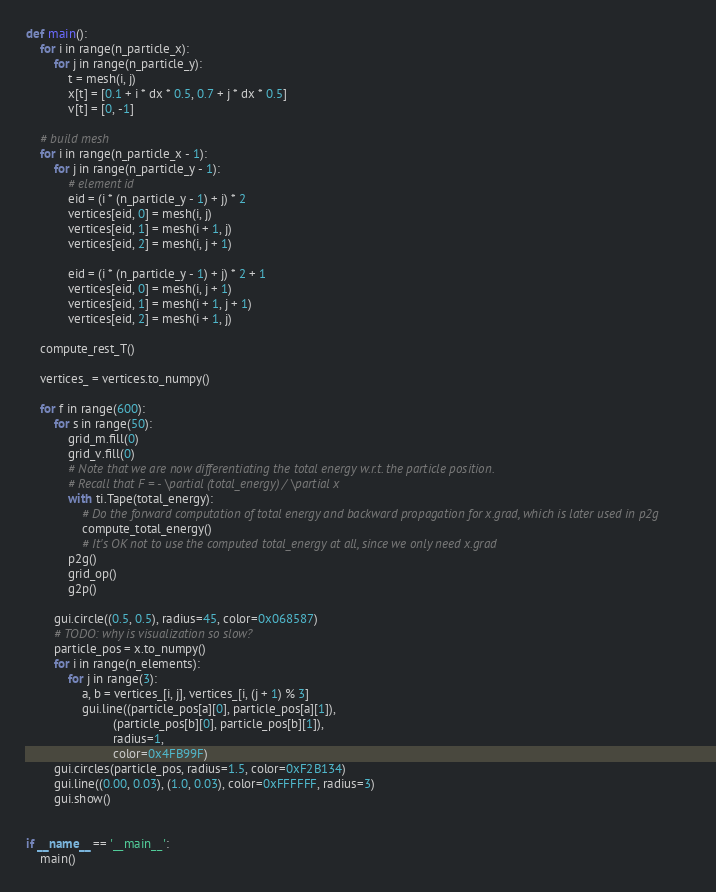Convert code to text. <code><loc_0><loc_0><loc_500><loc_500><_Python_>def main():
    for i in range(n_particle_x):
        for j in range(n_particle_y):
            t = mesh(i, j)
            x[t] = [0.1 + i * dx * 0.5, 0.7 + j * dx * 0.5]
            v[t] = [0, -1]

    # build mesh
    for i in range(n_particle_x - 1):
        for j in range(n_particle_y - 1):
            # element id
            eid = (i * (n_particle_y - 1) + j) * 2
            vertices[eid, 0] = mesh(i, j)
            vertices[eid, 1] = mesh(i + 1, j)
            vertices[eid, 2] = mesh(i, j + 1)

            eid = (i * (n_particle_y - 1) + j) * 2 + 1
            vertices[eid, 0] = mesh(i, j + 1)
            vertices[eid, 1] = mesh(i + 1, j + 1)
            vertices[eid, 2] = mesh(i + 1, j)

    compute_rest_T()

    vertices_ = vertices.to_numpy()

    for f in range(600):
        for s in range(50):
            grid_m.fill(0)
            grid_v.fill(0)
            # Note that we are now differentiating the total energy w.r.t. the particle position.
            # Recall that F = - \partial (total_energy) / \partial x
            with ti.Tape(total_energy):
                # Do the forward computation of total energy and backward propagation for x.grad, which is later used in p2g
                compute_total_energy()
                # It's OK not to use the computed total_energy at all, since we only need x.grad
            p2g()
            grid_op()
            g2p()

        gui.circle((0.5, 0.5), radius=45, color=0x068587)
        # TODO: why is visualization so slow?
        particle_pos = x.to_numpy()
        for i in range(n_elements):
            for j in range(3):
                a, b = vertices_[i, j], vertices_[i, (j + 1) % 3]
                gui.line((particle_pos[a][0], particle_pos[a][1]),
                         (particle_pos[b][0], particle_pos[b][1]),
                         radius=1,
                         color=0x4FB99F)
        gui.circles(particle_pos, radius=1.5, color=0xF2B134)
        gui.line((0.00, 0.03), (1.0, 0.03), color=0xFFFFFF, radius=3)
        gui.show()


if __name__ == '__main__':
    main()
</code> 